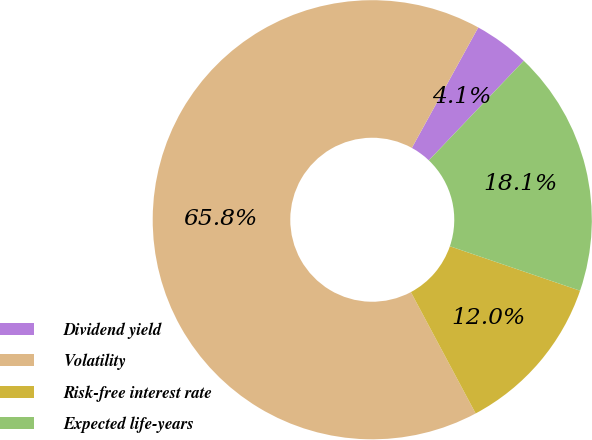Convert chart. <chart><loc_0><loc_0><loc_500><loc_500><pie_chart><fcel>Dividend yield<fcel>Volatility<fcel>Risk-free interest rate<fcel>Expected life-years<nl><fcel>4.1%<fcel>65.82%<fcel>11.96%<fcel>18.12%<nl></chart> 